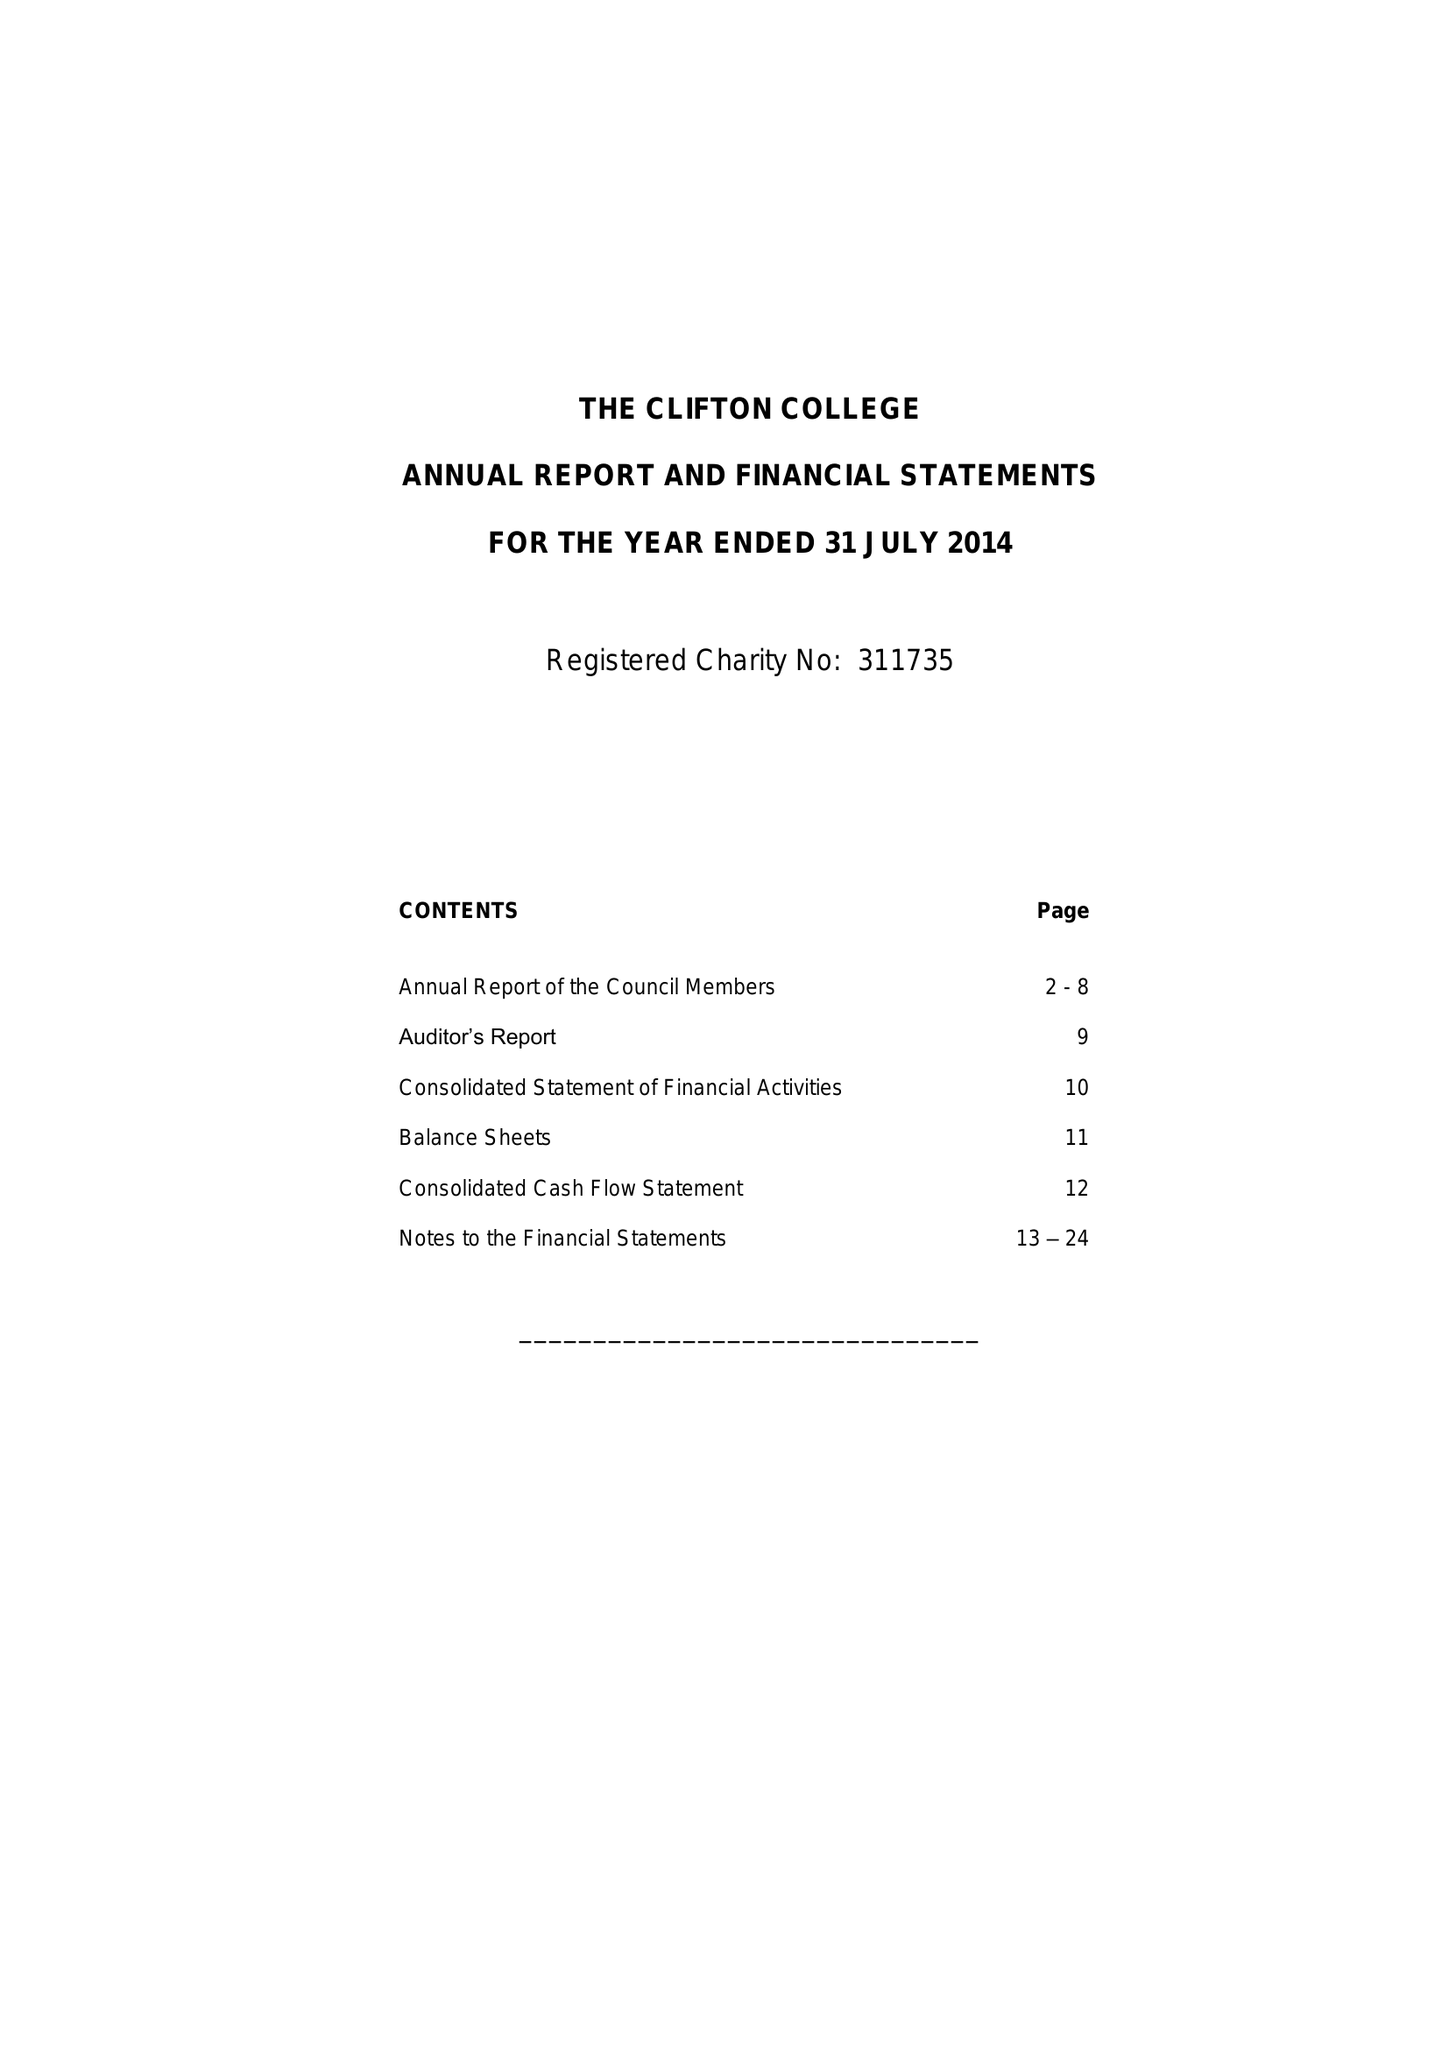What is the value for the charity_number?
Answer the question using a single word or phrase. 311735 